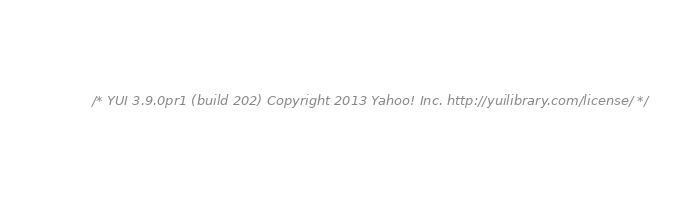<code> <loc_0><loc_0><loc_500><loc_500><_CSS_>/* YUI 3.9.0pr1 (build 202) Copyright 2013 Yahoo! Inc. http://yuilibrary.com/license/ */</code> 